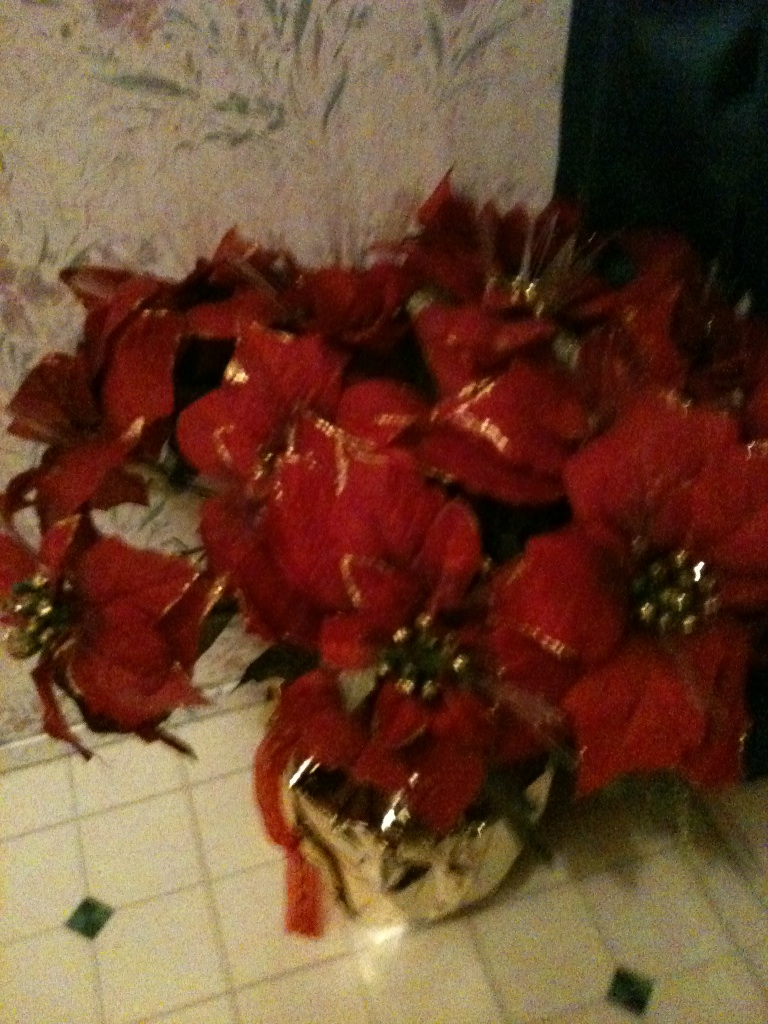How might these flowers be arranged differently for a holiday centerpiece? To create a stunning holiday centerpiece, you could place these red poinsettias in a large, decorative bowl or basket lined with festive greenery such as pine branches or holly. Adding elements like pine cones, cinnamon sticks, and small ornaments would enhance the seasonal theme. Arrange the poinsettias in a way that allows them to cascade slightly over the edges, creating a lush and inviting look. Lighting the centerpiece with a few strategically placed LED candles would add a warm, magical glow, perfect for a cozy holiday dinner setting. 